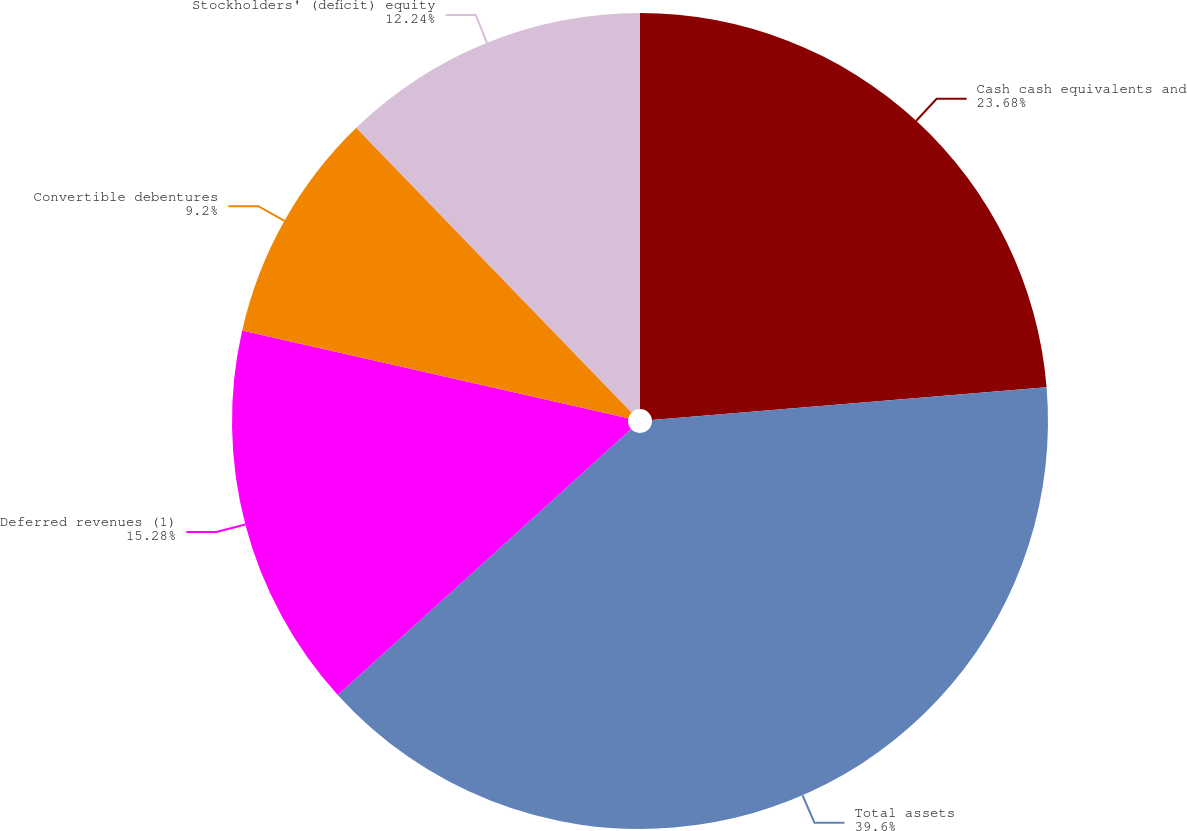Convert chart to OTSL. <chart><loc_0><loc_0><loc_500><loc_500><pie_chart><fcel>Cash cash equivalents and<fcel>Total assets<fcel>Deferred revenues (1)<fcel>Convertible debentures<fcel>Stockholders' (deficit) equity<nl><fcel>23.68%<fcel>39.6%<fcel>15.28%<fcel>9.2%<fcel>12.24%<nl></chart> 